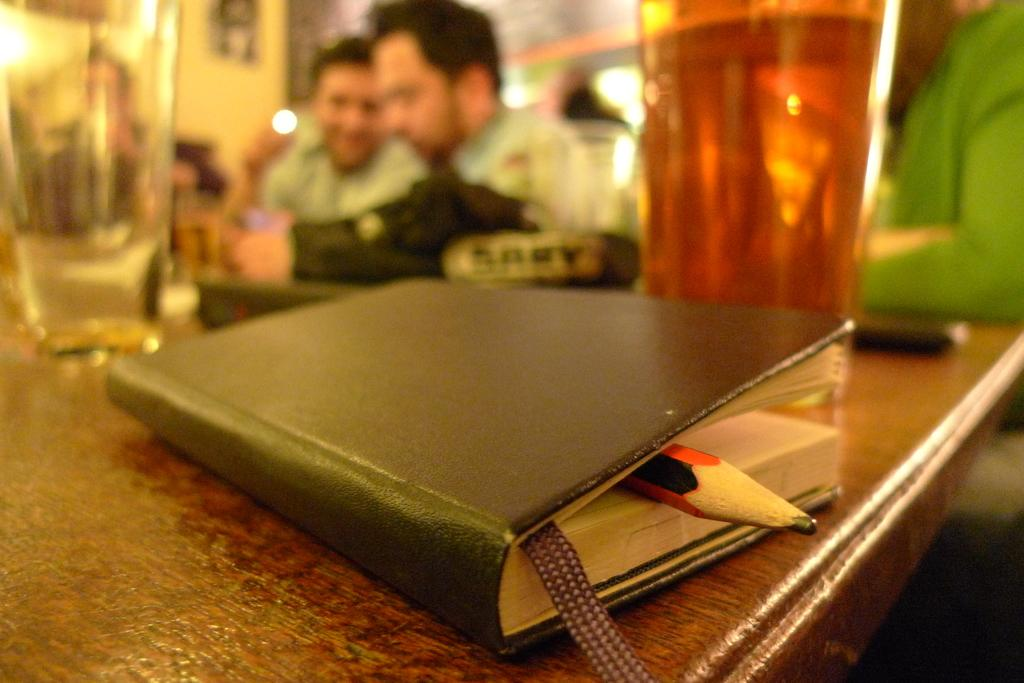How many people are in the image? There are two men in the image. What are the men doing in the image? The men are sitting in front of a table. What objects can be seen on the table? There are drinking glasses and a dairy product on the table. Can you describe any writing utensils in the image? Yes, there is a pencil visible in the image. How would you describe the background of the image? The background of the image is blurry. Is the bucket used for carrying water visible in the image? There is no bucket visible in the image. What is the heart rate of the man on the left in the image? The image does not provide any information about the heart rate of the men in the image. 